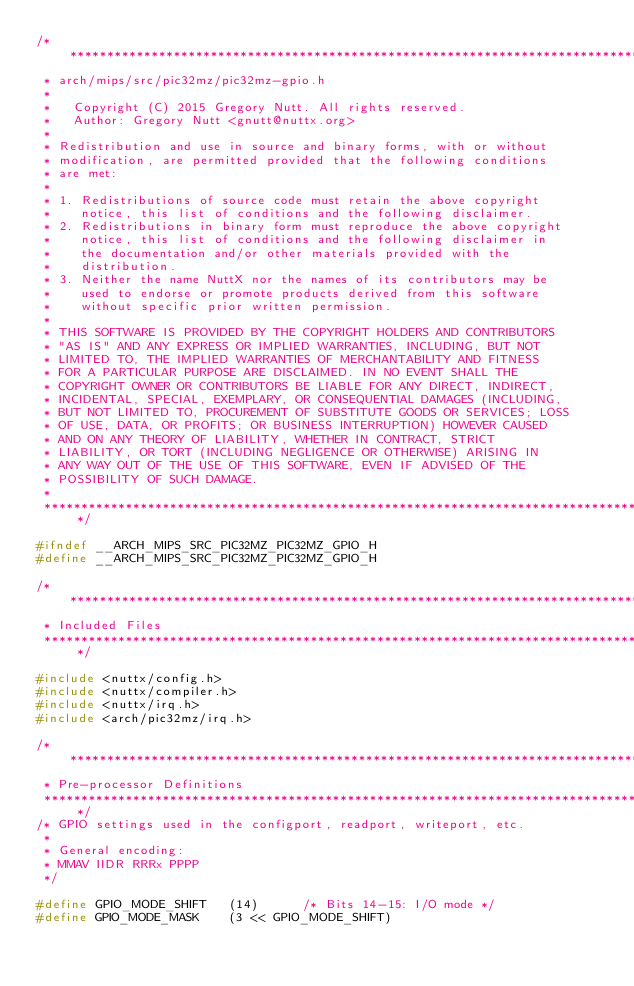<code> <loc_0><loc_0><loc_500><loc_500><_C_>/************************************************************************************
 * arch/mips/src/pic32mz/pic32mz-gpio.h
 *
 *   Copyright (C) 2015 Gregory Nutt. All rights reserved.
 *   Author: Gregory Nutt <gnutt@nuttx.org>
 *
 * Redistribution and use in source and binary forms, with or without
 * modification, are permitted provided that the following conditions
 * are met:
 *
 * 1. Redistributions of source code must retain the above copyright
 *    notice, this list of conditions and the following disclaimer.
 * 2. Redistributions in binary form must reproduce the above copyright
 *    notice, this list of conditions and the following disclaimer in
 *    the documentation and/or other materials provided with the
 *    distribution.
 * 3. Neither the name NuttX nor the names of its contributors may be
 *    used to endorse or promote products derived from this software
 *    without specific prior written permission.
 *
 * THIS SOFTWARE IS PROVIDED BY THE COPYRIGHT HOLDERS AND CONTRIBUTORS
 * "AS IS" AND ANY EXPRESS OR IMPLIED WARRANTIES, INCLUDING, BUT NOT
 * LIMITED TO, THE IMPLIED WARRANTIES OF MERCHANTABILITY AND FITNESS
 * FOR A PARTICULAR PURPOSE ARE DISCLAIMED. IN NO EVENT SHALL THE
 * COPYRIGHT OWNER OR CONTRIBUTORS BE LIABLE FOR ANY DIRECT, INDIRECT,
 * INCIDENTAL, SPECIAL, EXEMPLARY, OR CONSEQUENTIAL DAMAGES (INCLUDING,
 * BUT NOT LIMITED TO, PROCUREMENT OF SUBSTITUTE GOODS OR SERVICES; LOSS
 * OF USE, DATA, OR PROFITS; OR BUSINESS INTERRUPTION) HOWEVER CAUSED
 * AND ON ANY THEORY OF LIABILITY, WHETHER IN CONTRACT, STRICT
 * LIABILITY, OR TORT (INCLUDING NEGLIGENCE OR OTHERWISE) ARISING IN
 * ANY WAY OUT OF THE USE OF THIS SOFTWARE, EVEN IF ADVISED OF THE
 * POSSIBILITY OF SUCH DAMAGE.
 *
 ************************************************************************************/

#ifndef __ARCH_MIPS_SRC_PIC32MZ_PIC32MZ_GPIO_H
#define __ARCH_MIPS_SRC_PIC32MZ_PIC32MZ_GPIO_H

/************************************************************************************
 * Included Files
 ************************************************************************************/

#include <nuttx/config.h>
#include <nuttx/compiler.h>
#include <nuttx/irq.h>
#include <arch/pic32mz/irq.h>

/************************************************************************************
 * Pre-processor Definitions
 ************************************************************************************/
/* GPIO settings used in the configport, readport, writeport, etc.
 *
 * General encoding:
 * MMAV IIDR RRRx PPPP
 */

#define GPIO_MODE_SHIFT   (14)      /* Bits 14-15: I/O mode */
#define GPIO_MODE_MASK    (3 << GPIO_MODE_SHIFT)</code> 